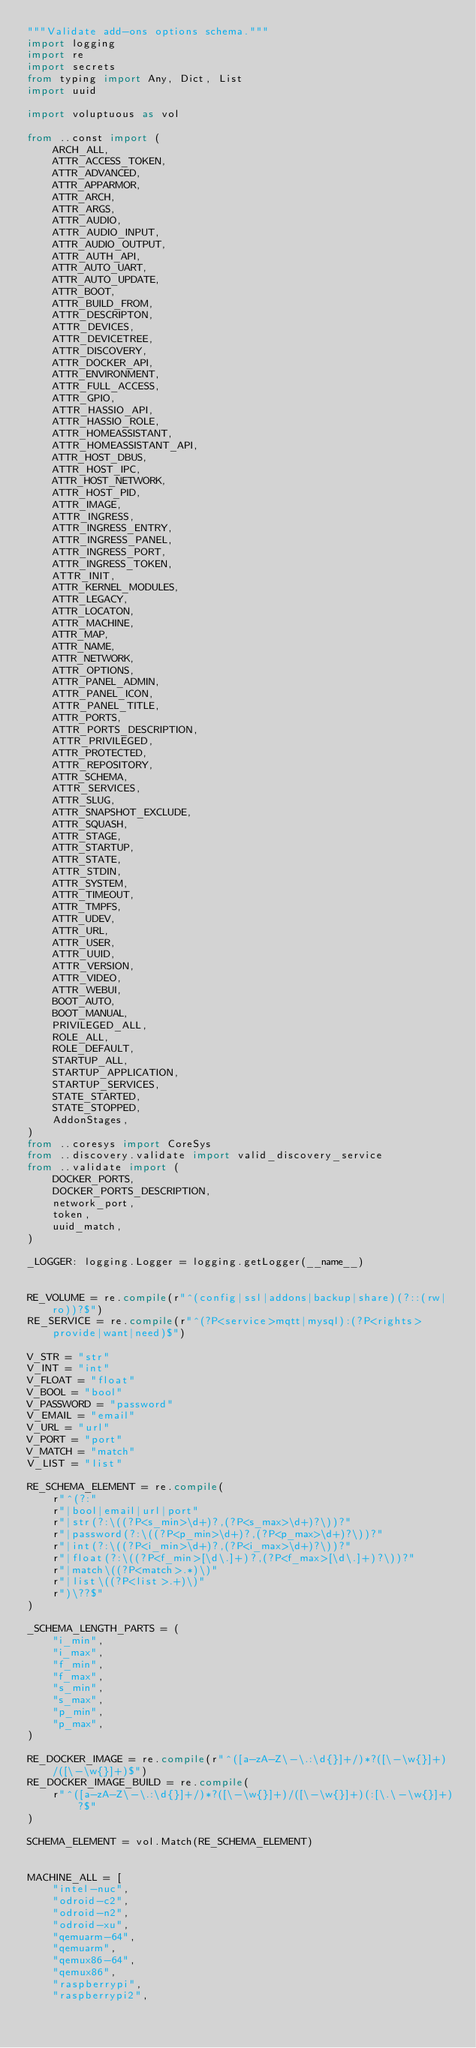Convert code to text. <code><loc_0><loc_0><loc_500><loc_500><_Python_>"""Validate add-ons options schema."""
import logging
import re
import secrets
from typing import Any, Dict, List
import uuid

import voluptuous as vol

from ..const import (
    ARCH_ALL,
    ATTR_ACCESS_TOKEN,
    ATTR_ADVANCED,
    ATTR_APPARMOR,
    ATTR_ARCH,
    ATTR_ARGS,
    ATTR_AUDIO,
    ATTR_AUDIO_INPUT,
    ATTR_AUDIO_OUTPUT,
    ATTR_AUTH_API,
    ATTR_AUTO_UART,
    ATTR_AUTO_UPDATE,
    ATTR_BOOT,
    ATTR_BUILD_FROM,
    ATTR_DESCRIPTON,
    ATTR_DEVICES,
    ATTR_DEVICETREE,
    ATTR_DISCOVERY,
    ATTR_DOCKER_API,
    ATTR_ENVIRONMENT,
    ATTR_FULL_ACCESS,
    ATTR_GPIO,
    ATTR_HASSIO_API,
    ATTR_HASSIO_ROLE,
    ATTR_HOMEASSISTANT,
    ATTR_HOMEASSISTANT_API,
    ATTR_HOST_DBUS,
    ATTR_HOST_IPC,
    ATTR_HOST_NETWORK,
    ATTR_HOST_PID,
    ATTR_IMAGE,
    ATTR_INGRESS,
    ATTR_INGRESS_ENTRY,
    ATTR_INGRESS_PANEL,
    ATTR_INGRESS_PORT,
    ATTR_INGRESS_TOKEN,
    ATTR_INIT,
    ATTR_KERNEL_MODULES,
    ATTR_LEGACY,
    ATTR_LOCATON,
    ATTR_MACHINE,
    ATTR_MAP,
    ATTR_NAME,
    ATTR_NETWORK,
    ATTR_OPTIONS,
    ATTR_PANEL_ADMIN,
    ATTR_PANEL_ICON,
    ATTR_PANEL_TITLE,
    ATTR_PORTS,
    ATTR_PORTS_DESCRIPTION,
    ATTR_PRIVILEGED,
    ATTR_PROTECTED,
    ATTR_REPOSITORY,
    ATTR_SCHEMA,
    ATTR_SERVICES,
    ATTR_SLUG,
    ATTR_SNAPSHOT_EXCLUDE,
    ATTR_SQUASH,
    ATTR_STAGE,
    ATTR_STARTUP,
    ATTR_STATE,
    ATTR_STDIN,
    ATTR_SYSTEM,
    ATTR_TIMEOUT,
    ATTR_TMPFS,
    ATTR_UDEV,
    ATTR_URL,
    ATTR_USER,
    ATTR_UUID,
    ATTR_VERSION,
    ATTR_VIDEO,
    ATTR_WEBUI,
    BOOT_AUTO,
    BOOT_MANUAL,
    PRIVILEGED_ALL,
    ROLE_ALL,
    ROLE_DEFAULT,
    STARTUP_ALL,
    STARTUP_APPLICATION,
    STARTUP_SERVICES,
    STATE_STARTED,
    STATE_STOPPED,
    AddonStages,
)
from ..coresys import CoreSys
from ..discovery.validate import valid_discovery_service
from ..validate import (
    DOCKER_PORTS,
    DOCKER_PORTS_DESCRIPTION,
    network_port,
    token,
    uuid_match,
)

_LOGGER: logging.Logger = logging.getLogger(__name__)


RE_VOLUME = re.compile(r"^(config|ssl|addons|backup|share)(?::(rw|ro))?$")
RE_SERVICE = re.compile(r"^(?P<service>mqtt|mysql):(?P<rights>provide|want|need)$")

V_STR = "str"
V_INT = "int"
V_FLOAT = "float"
V_BOOL = "bool"
V_PASSWORD = "password"
V_EMAIL = "email"
V_URL = "url"
V_PORT = "port"
V_MATCH = "match"
V_LIST = "list"

RE_SCHEMA_ELEMENT = re.compile(
    r"^(?:"
    r"|bool|email|url|port"
    r"|str(?:\((?P<s_min>\d+)?,(?P<s_max>\d+)?\))?"
    r"|password(?:\((?P<p_min>\d+)?,(?P<p_max>\d+)?\))?"
    r"|int(?:\((?P<i_min>\d+)?,(?P<i_max>\d+)?\))?"
    r"|float(?:\((?P<f_min>[\d\.]+)?,(?P<f_max>[\d\.]+)?\))?"
    r"|match\((?P<match>.*)\)"
    r"|list\((?P<list>.+)\)"
    r")\??$"
)

_SCHEMA_LENGTH_PARTS = (
    "i_min",
    "i_max",
    "f_min",
    "f_max",
    "s_min",
    "s_max",
    "p_min",
    "p_max",
)

RE_DOCKER_IMAGE = re.compile(r"^([a-zA-Z\-\.:\d{}]+/)*?([\-\w{}]+)/([\-\w{}]+)$")
RE_DOCKER_IMAGE_BUILD = re.compile(
    r"^([a-zA-Z\-\.:\d{}]+/)*?([\-\w{}]+)/([\-\w{}]+)(:[\.\-\w{}]+)?$"
)

SCHEMA_ELEMENT = vol.Match(RE_SCHEMA_ELEMENT)


MACHINE_ALL = [
    "intel-nuc",
    "odroid-c2",
    "odroid-n2",
    "odroid-xu",
    "qemuarm-64",
    "qemuarm",
    "qemux86-64",
    "qemux86",
    "raspberrypi",
    "raspberrypi2",</code> 